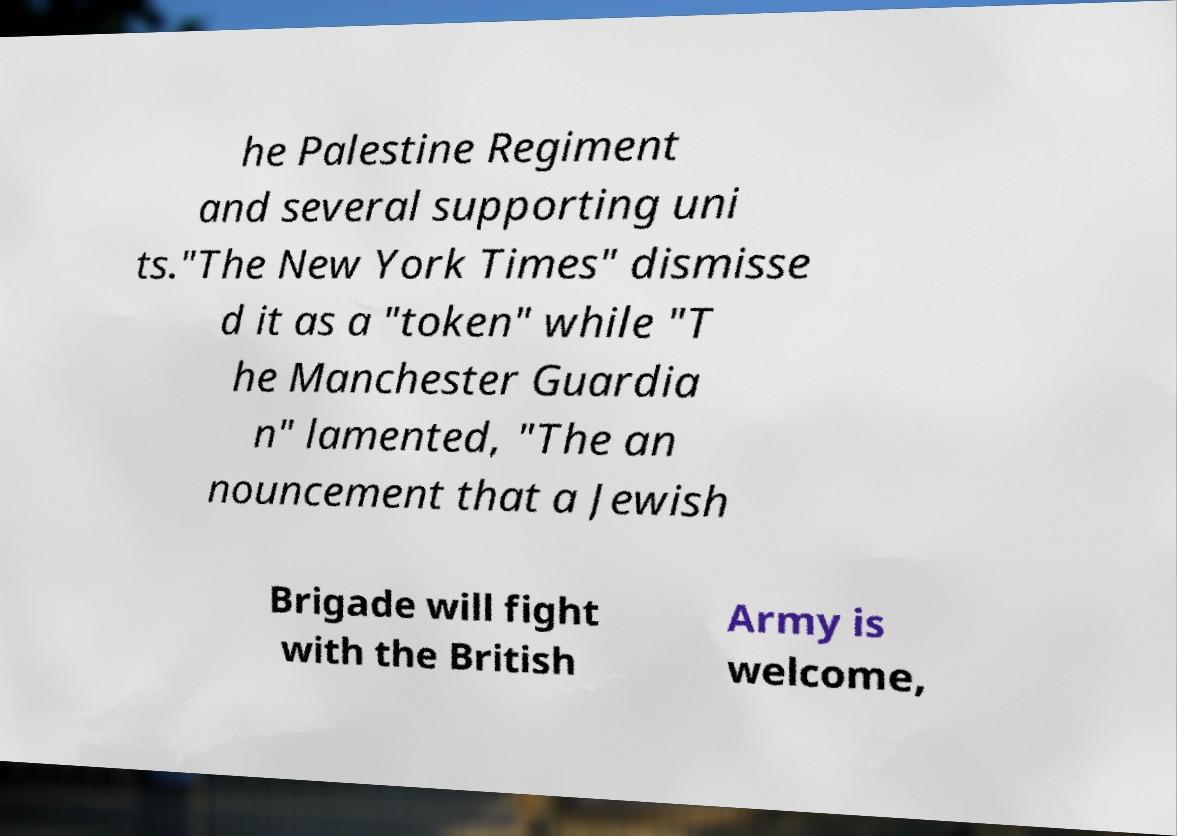I need the written content from this picture converted into text. Can you do that? he Palestine Regiment and several supporting uni ts."The New York Times" dismisse d it as a "token" while "T he Manchester Guardia n" lamented, "The an nouncement that a Jewish Brigade will fight with the British Army is welcome, 